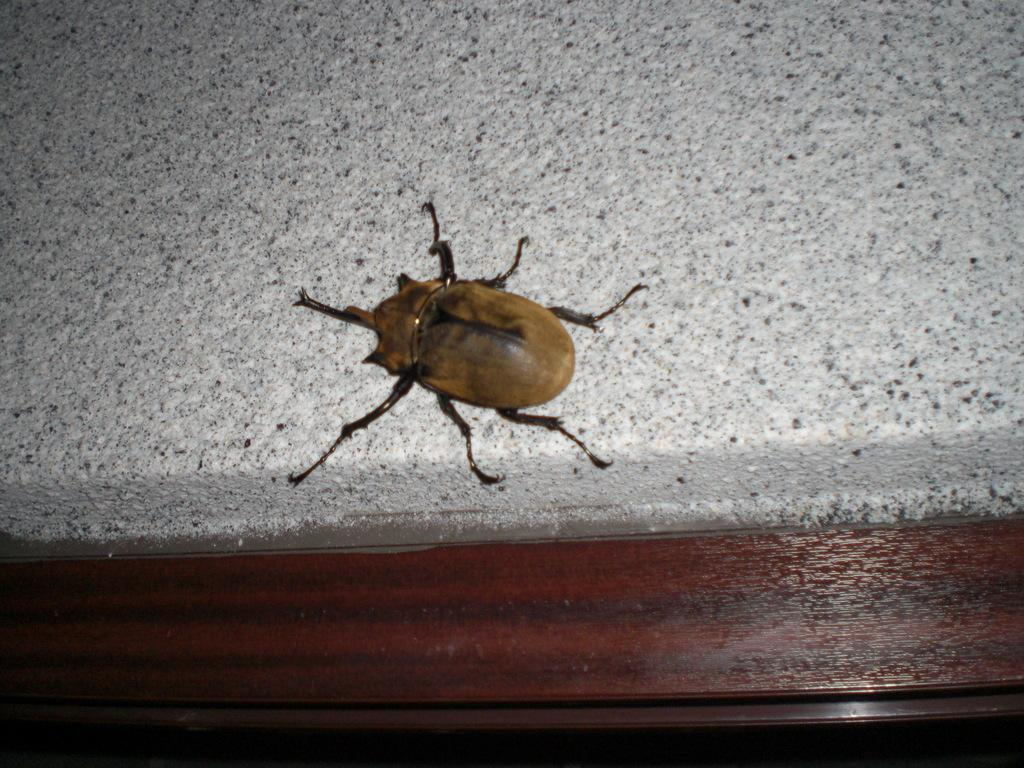What type of creature is present in the image? There is an insect in the image. What colors can be seen on the insect? The insect has brown and black colors. What is the background or surface that the insect is on? The insect is on a gray surface. How many babies are visible in the image? There are no babies present in the image; it features an insect on a gray surface. What is the condition of the street in the image? There is no street present in the image, so it is not possible to determine the condition of a street. 